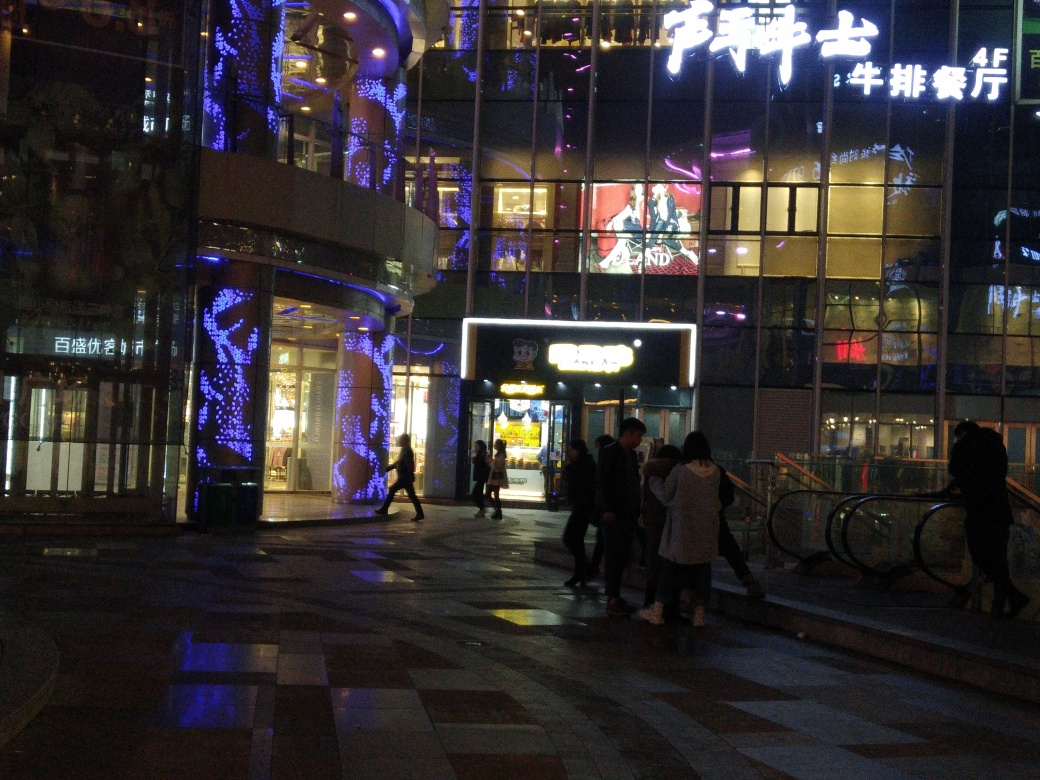What kind of mood or atmosphere does this image evoke? The image evokes a mood of urban excitement and vibrancy. The illuminations against the night sky create a sense of energy and activity that's typical of a bustling cityscape in the evening. The lights also cast a warm and welcoming glow that invites exploration and enjoyment of the city's offerings. 